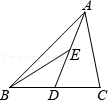If in triangle ABC, point D is the midpoint of side BC and point E is the midpoint of side AD, and the area of triangle ABC measures 10 units, what is the area of triangle ABE? Let's denote the area of triangle ABE as X units. Since E is precisely at the midpoint of AD, AE and DE are of equal lengths. This implies that triangles ABE and BDE are congruent, meaning each has an area of X units. Furthermore, with D being at the midpoint of BC, BD equals CD. This symmetry shows that triangles ABD and ADC are congruent as well, each covering double the area of triangle ABE, so their areas are 2X each. Together, these calculations propose that triangle ABC, encompassing triangles ABD and ADC, has a total area of 4X. Since we know this is 10 units, dividing 10 by 4 gives X = 2.5. Hence, the area of triangle ABE is 2.5 square units. This precise division of the triangle based on midpoints provides us with a clear and insightful look into geometric properties and their implications on area calculations. 